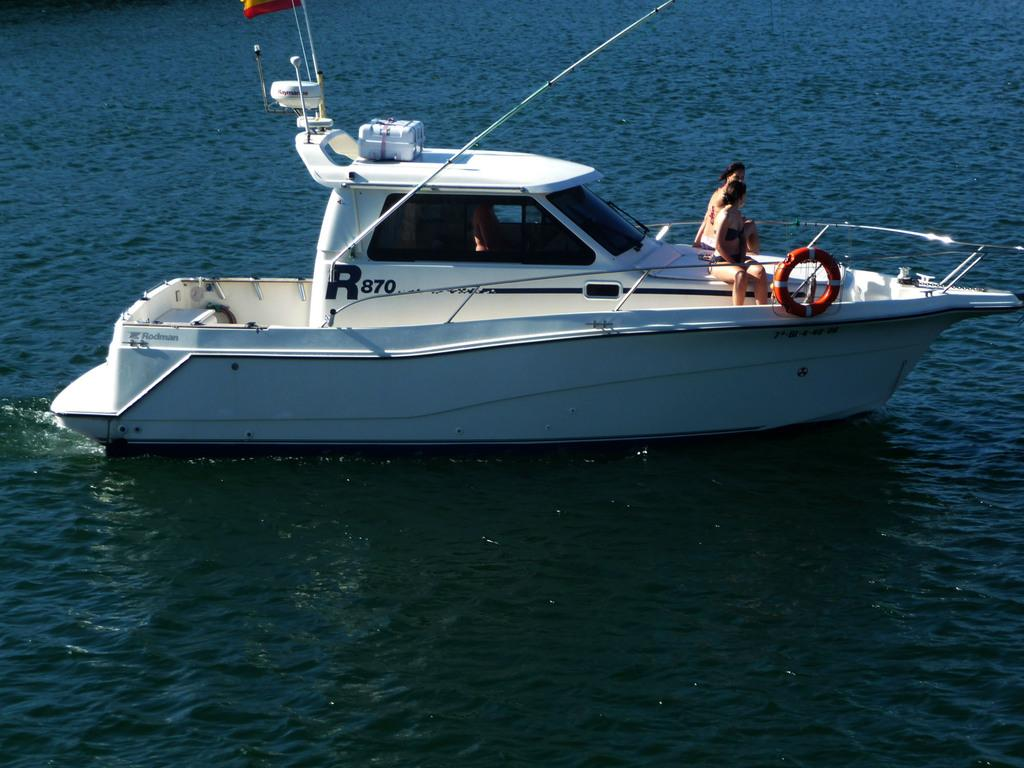What is the main subject in the center of the image? There is a yacht in the center of the image. Are there any people on the yacht? Yes, there are people on the yacht. What type of environment is visible in the image? There is a water body visible in the image. How does the yacht contribute to world peace in the image? The image does not depict any information about world peace or the yacht's role in it. 